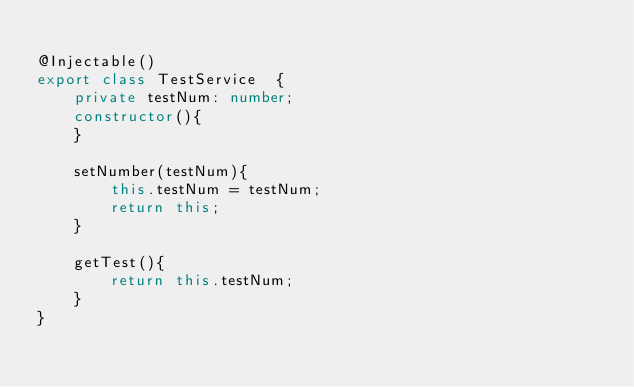Convert code to text. <code><loc_0><loc_0><loc_500><loc_500><_TypeScript_>
@Injectable()
export class TestService  {
    private testNum: number;
    constructor(){
    }

    setNumber(testNum){
        this.testNum = testNum;
        return this;
    }

    getTest(){
        return this.testNum;
    }
}</code> 